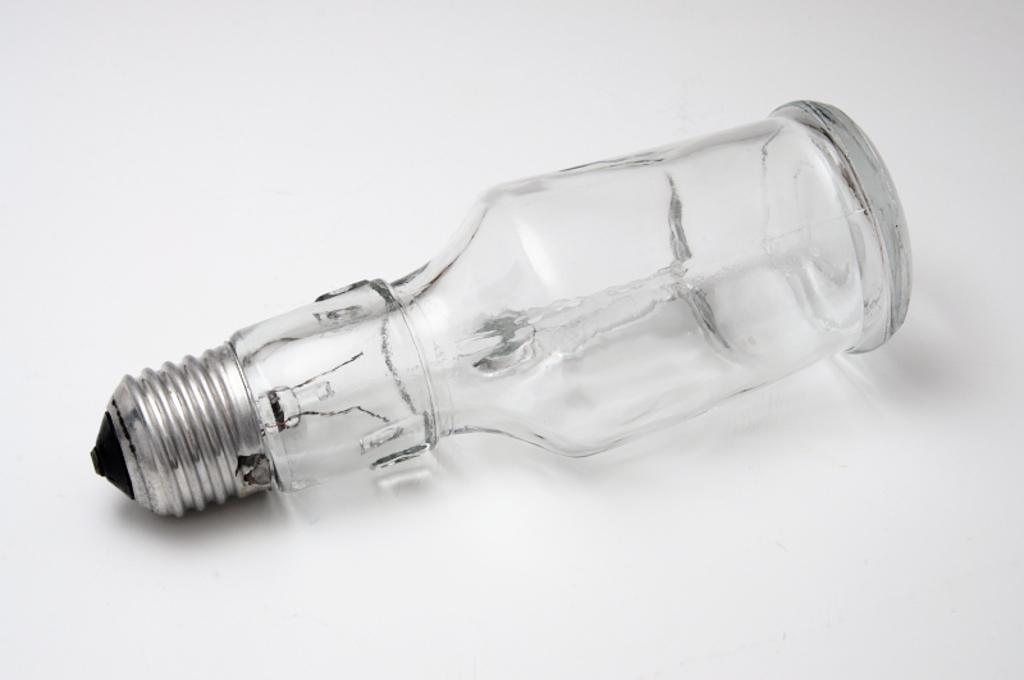What is the color of the background in the image? The background of the image is white. What object can be seen on the white background? There is a glass bottle on the background. What feature of the glass bottle is mentioned in the facts? The glass bottle has a cap. What is the tendency of the snow to melt in the image? There is no snow present in the image, so it's not possible to determine its tendency to melt. 